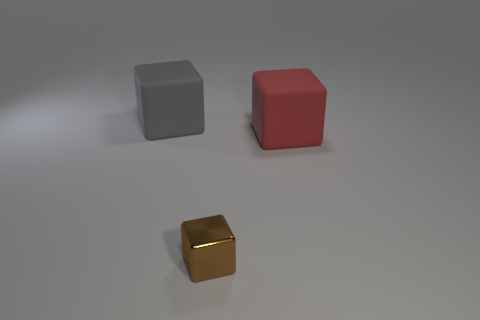Are there any other things that are the same size as the brown thing?
Make the answer very short. No. Are there any other things that are the same material as the tiny brown cube?
Keep it short and to the point. No. Is the number of small objects to the left of the large gray cube the same as the number of red objects that are behind the big red object?
Your answer should be compact. Yes. The gray rubber object that is the same shape as the red matte thing is what size?
Provide a succinct answer. Large. What is the shape of the tiny thing that is in front of the red object?
Make the answer very short. Cube. Do the big object that is on the right side of the gray matte cube and the cube that is in front of the big red object have the same material?
Your response must be concise. No. The tiny thing has what shape?
Ensure brevity in your answer.  Cube. Are there the same number of brown metal things on the right side of the brown block and small purple rubber balls?
Give a very brief answer. Yes. Are there any tiny yellow blocks that have the same material as the small brown block?
Give a very brief answer. No. There is a large rubber object that is in front of the large gray matte block; is it the same shape as the big rubber object left of the small block?
Offer a terse response. Yes. 